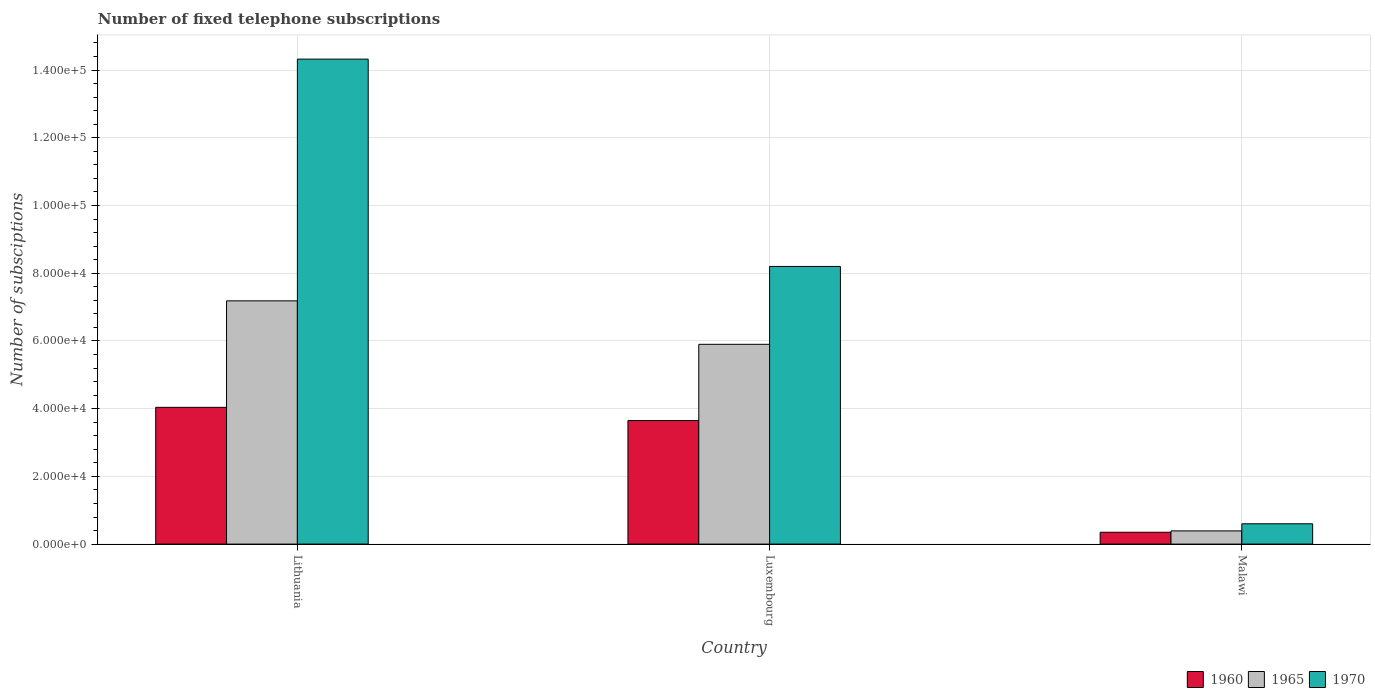How many different coloured bars are there?
Provide a short and direct response. 3. How many groups of bars are there?
Make the answer very short. 3. Are the number of bars on each tick of the X-axis equal?
Offer a terse response. Yes. How many bars are there on the 3rd tick from the left?
Keep it short and to the point. 3. How many bars are there on the 2nd tick from the right?
Keep it short and to the point. 3. What is the label of the 1st group of bars from the left?
Ensure brevity in your answer.  Lithuania. In how many cases, is the number of bars for a given country not equal to the number of legend labels?
Offer a very short reply. 0. What is the number of fixed telephone subscriptions in 1960 in Malawi?
Your response must be concise. 3500. Across all countries, what is the maximum number of fixed telephone subscriptions in 1960?
Give a very brief answer. 4.04e+04. Across all countries, what is the minimum number of fixed telephone subscriptions in 1960?
Give a very brief answer. 3500. In which country was the number of fixed telephone subscriptions in 1960 maximum?
Provide a succinct answer. Lithuania. In which country was the number of fixed telephone subscriptions in 1960 minimum?
Offer a terse response. Malawi. What is the total number of fixed telephone subscriptions in 1965 in the graph?
Offer a very short reply. 1.35e+05. What is the difference between the number of fixed telephone subscriptions in 1960 in Luxembourg and that in Malawi?
Ensure brevity in your answer.  3.30e+04. What is the difference between the number of fixed telephone subscriptions in 1970 in Luxembourg and the number of fixed telephone subscriptions in 1965 in Lithuania?
Your response must be concise. 1.02e+04. What is the average number of fixed telephone subscriptions in 1970 per country?
Keep it short and to the point. 7.71e+04. What is the difference between the number of fixed telephone subscriptions of/in 1970 and number of fixed telephone subscriptions of/in 1960 in Luxembourg?
Give a very brief answer. 4.55e+04. In how many countries, is the number of fixed telephone subscriptions in 1965 greater than 16000?
Keep it short and to the point. 2. What is the ratio of the number of fixed telephone subscriptions in 1960 in Luxembourg to that in Malawi?
Make the answer very short. 10.42. Is the difference between the number of fixed telephone subscriptions in 1970 in Lithuania and Luxembourg greater than the difference between the number of fixed telephone subscriptions in 1960 in Lithuania and Luxembourg?
Make the answer very short. Yes. What is the difference between the highest and the second highest number of fixed telephone subscriptions in 1970?
Give a very brief answer. -6.12e+04. What is the difference between the highest and the lowest number of fixed telephone subscriptions in 1970?
Give a very brief answer. 1.37e+05. What does the 2nd bar from the right in Luxembourg represents?
Make the answer very short. 1965. Are all the bars in the graph horizontal?
Offer a terse response. No. What is the difference between two consecutive major ticks on the Y-axis?
Offer a very short reply. 2.00e+04. Are the values on the major ticks of Y-axis written in scientific E-notation?
Ensure brevity in your answer.  Yes. Where does the legend appear in the graph?
Ensure brevity in your answer.  Bottom right. How many legend labels are there?
Your response must be concise. 3. How are the legend labels stacked?
Give a very brief answer. Horizontal. What is the title of the graph?
Your response must be concise. Number of fixed telephone subscriptions. Does "1990" appear as one of the legend labels in the graph?
Provide a short and direct response. No. What is the label or title of the X-axis?
Your answer should be very brief. Country. What is the label or title of the Y-axis?
Your answer should be very brief. Number of subsciptions. What is the Number of subsciptions of 1960 in Lithuania?
Make the answer very short. 4.04e+04. What is the Number of subsciptions of 1965 in Lithuania?
Your answer should be compact. 7.18e+04. What is the Number of subsciptions in 1970 in Lithuania?
Provide a short and direct response. 1.43e+05. What is the Number of subsciptions in 1960 in Luxembourg?
Make the answer very short. 3.65e+04. What is the Number of subsciptions of 1965 in Luxembourg?
Provide a short and direct response. 5.90e+04. What is the Number of subsciptions of 1970 in Luxembourg?
Your answer should be very brief. 8.20e+04. What is the Number of subsciptions in 1960 in Malawi?
Give a very brief answer. 3500. What is the Number of subsciptions in 1965 in Malawi?
Offer a terse response. 3900. What is the Number of subsciptions in 1970 in Malawi?
Make the answer very short. 6000. Across all countries, what is the maximum Number of subsciptions of 1960?
Ensure brevity in your answer.  4.04e+04. Across all countries, what is the maximum Number of subsciptions in 1965?
Provide a succinct answer. 7.18e+04. Across all countries, what is the maximum Number of subsciptions of 1970?
Provide a succinct answer. 1.43e+05. Across all countries, what is the minimum Number of subsciptions of 1960?
Provide a short and direct response. 3500. Across all countries, what is the minimum Number of subsciptions in 1965?
Keep it short and to the point. 3900. Across all countries, what is the minimum Number of subsciptions in 1970?
Give a very brief answer. 6000. What is the total Number of subsciptions of 1960 in the graph?
Provide a succinct answer. 8.04e+04. What is the total Number of subsciptions in 1965 in the graph?
Your answer should be very brief. 1.35e+05. What is the total Number of subsciptions in 1970 in the graph?
Your answer should be very brief. 2.31e+05. What is the difference between the Number of subsciptions of 1960 in Lithuania and that in Luxembourg?
Keep it short and to the point. 3902. What is the difference between the Number of subsciptions in 1965 in Lithuania and that in Luxembourg?
Make the answer very short. 1.28e+04. What is the difference between the Number of subsciptions of 1970 in Lithuania and that in Luxembourg?
Offer a very short reply. 6.12e+04. What is the difference between the Number of subsciptions in 1960 in Lithuania and that in Malawi?
Your response must be concise. 3.69e+04. What is the difference between the Number of subsciptions in 1965 in Lithuania and that in Malawi?
Offer a very short reply. 6.79e+04. What is the difference between the Number of subsciptions of 1970 in Lithuania and that in Malawi?
Give a very brief answer. 1.37e+05. What is the difference between the Number of subsciptions in 1960 in Luxembourg and that in Malawi?
Ensure brevity in your answer.  3.30e+04. What is the difference between the Number of subsciptions of 1965 in Luxembourg and that in Malawi?
Offer a terse response. 5.51e+04. What is the difference between the Number of subsciptions in 1970 in Luxembourg and that in Malawi?
Ensure brevity in your answer.  7.60e+04. What is the difference between the Number of subsciptions of 1960 in Lithuania and the Number of subsciptions of 1965 in Luxembourg?
Offer a terse response. -1.86e+04. What is the difference between the Number of subsciptions in 1960 in Lithuania and the Number of subsciptions in 1970 in Luxembourg?
Provide a succinct answer. -4.16e+04. What is the difference between the Number of subsciptions of 1965 in Lithuania and the Number of subsciptions of 1970 in Luxembourg?
Give a very brief answer. -1.02e+04. What is the difference between the Number of subsciptions in 1960 in Lithuania and the Number of subsciptions in 1965 in Malawi?
Make the answer very short. 3.65e+04. What is the difference between the Number of subsciptions in 1960 in Lithuania and the Number of subsciptions in 1970 in Malawi?
Give a very brief answer. 3.44e+04. What is the difference between the Number of subsciptions of 1965 in Lithuania and the Number of subsciptions of 1970 in Malawi?
Your answer should be compact. 6.58e+04. What is the difference between the Number of subsciptions of 1960 in Luxembourg and the Number of subsciptions of 1965 in Malawi?
Your answer should be very brief. 3.26e+04. What is the difference between the Number of subsciptions of 1960 in Luxembourg and the Number of subsciptions of 1970 in Malawi?
Your answer should be compact. 3.05e+04. What is the difference between the Number of subsciptions of 1965 in Luxembourg and the Number of subsciptions of 1970 in Malawi?
Your answer should be compact. 5.30e+04. What is the average Number of subsciptions in 1960 per country?
Your answer should be very brief. 2.68e+04. What is the average Number of subsciptions in 1965 per country?
Your response must be concise. 4.49e+04. What is the average Number of subsciptions in 1970 per country?
Your answer should be compact. 7.71e+04. What is the difference between the Number of subsciptions in 1960 and Number of subsciptions in 1965 in Lithuania?
Your answer should be very brief. -3.15e+04. What is the difference between the Number of subsciptions of 1960 and Number of subsciptions of 1970 in Lithuania?
Provide a short and direct response. -1.03e+05. What is the difference between the Number of subsciptions in 1965 and Number of subsciptions in 1970 in Lithuania?
Ensure brevity in your answer.  -7.14e+04. What is the difference between the Number of subsciptions in 1960 and Number of subsciptions in 1965 in Luxembourg?
Your response must be concise. -2.25e+04. What is the difference between the Number of subsciptions in 1960 and Number of subsciptions in 1970 in Luxembourg?
Provide a short and direct response. -4.55e+04. What is the difference between the Number of subsciptions of 1965 and Number of subsciptions of 1970 in Luxembourg?
Ensure brevity in your answer.  -2.30e+04. What is the difference between the Number of subsciptions in 1960 and Number of subsciptions in 1965 in Malawi?
Give a very brief answer. -400. What is the difference between the Number of subsciptions in 1960 and Number of subsciptions in 1970 in Malawi?
Provide a short and direct response. -2500. What is the difference between the Number of subsciptions of 1965 and Number of subsciptions of 1970 in Malawi?
Provide a succinct answer. -2100. What is the ratio of the Number of subsciptions in 1960 in Lithuania to that in Luxembourg?
Make the answer very short. 1.11. What is the ratio of the Number of subsciptions in 1965 in Lithuania to that in Luxembourg?
Your answer should be very brief. 1.22. What is the ratio of the Number of subsciptions in 1970 in Lithuania to that in Luxembourg?
Your response must be concise. 1.75. What is the ratio of the Number of subsciptions in 1960 in Lithuania to that in Malawi?
Make the answer very short. 11.54. What is the ratio of the Number of subsciptions in 1965 in Lithuania to that in Malawi?
Ensure brevity in your answer.  18.42. What is the ratio of the Number of subsciptions of 1970 in Lithuania to that in Malawi?
Your answer should be very brief. 23.87. What is the ratio of the Number of subsciptions of 1960 in Luxembourg to that in Malawi?
Your answer should be compact. 10.42. What is the ratio of the Number of subsciptions of 1965 in Luxembourg to that in Malawi?
Your answer should be compact. 15.13. What is the ratio of the Number of subsciptions of 1970 in Luxembourg to that in Malawi?
Offer a terse response. 13.67. What is the difference between the highest and the second highest Number of subsciptions in 1960?
Offer a terse response. 3902. What is the difference between the highest and the second highest Number of subsciptions of 1965?
Keep it short and to the point. 1.28e+04. What is the difference between the highest and the second highest Number of subsciptions in 1970?
Your answer should be very brief. 6.12e+04. What is the difference between the highest and the lowest Number of subsciptions of 1960?
Keep it short and to the point. 3.69e+04. What is the difference between the highest and the lowest Number of subsciptions of 1965?
Your response must be concise. 6.79e+04. What is the difference between the highest and the lowest Number of subsciptions in 1970?
Provide a short and direct response. 1.37e+05. 